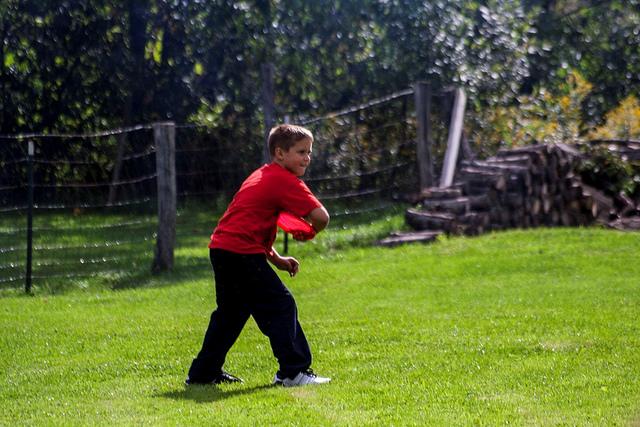Is this yard fenced in?
Be succinct. Yes. Which hand is the boy holding the Frisbee with?
Give a very brief answer. Right. Has the grass been recently mowed?
Give a very brief answer. Yes. What color is this guy's shirt?
Quick response, please. Red. 